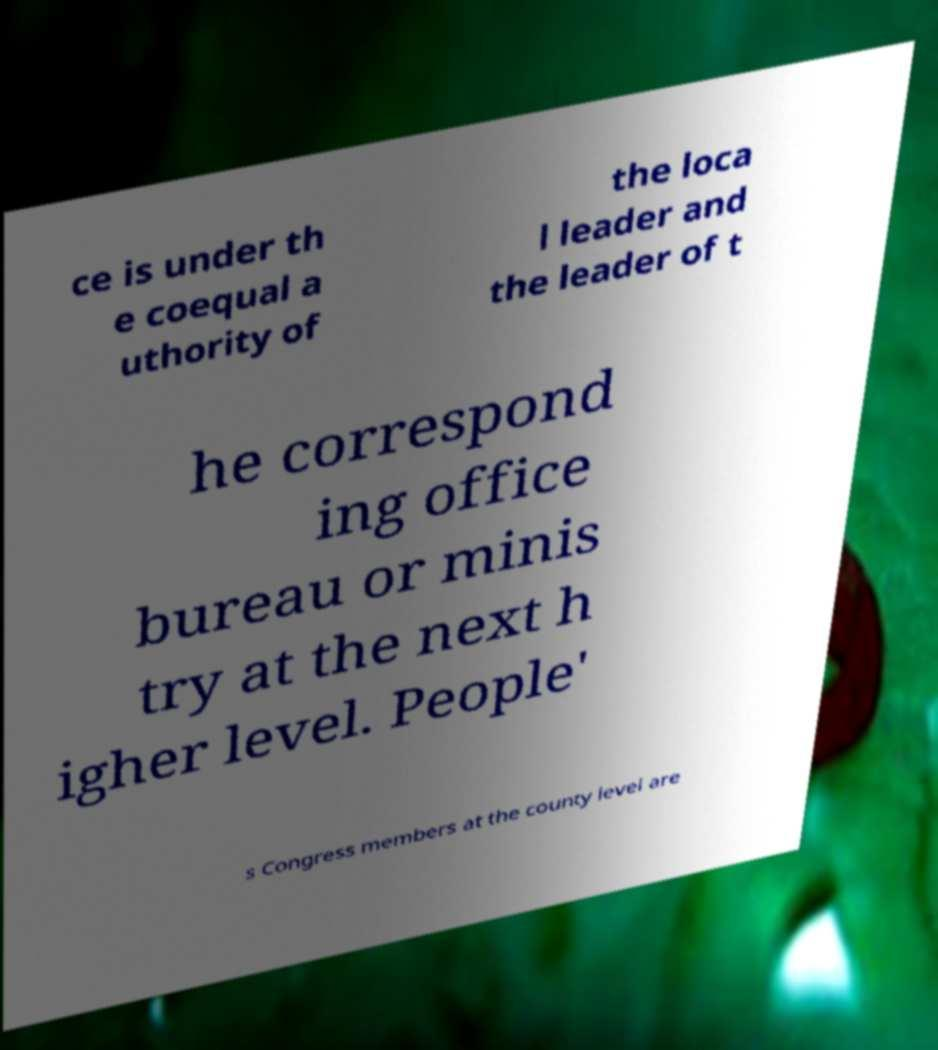Could you extract and type out the text from this image? ce is under th e coequal a uthority of the loca l leader and the leader of t he correspond ing office bureau or minis try at the next h igher level. People' s Congress members at the county level are 